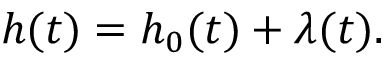Convert formula to latex. <formula><loc_0><loc_0><loc_500><loc_500>h ( t ) = h _ { 0 } ( t ) + \lambda ( t ) .</formula> 